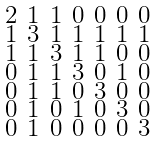<formula> <loc_0><loc_0><loc_500><loc_500>\begin{smallmatrix} 2 & 1 & 1 & 0 & 0 & 0 & 0 \\ 1 & 3 & 1 & 1 & 1 & 1 & 1 \\ 1 & 1 & 3 & 1 & 1 & 0 & 0 \\ 0 & 1 & 1 & 3 & 0 & 1 & 0 \\ 0 & 1 & 1 & 0 & 3 & 0 & 0 \\ 0 & 1 & 0 & 1 & 0 & 3 & 0 \\ 0 & 1 & 0 & 0 & 0 & 0 & 3 \end{smallmatrix}</formula> 